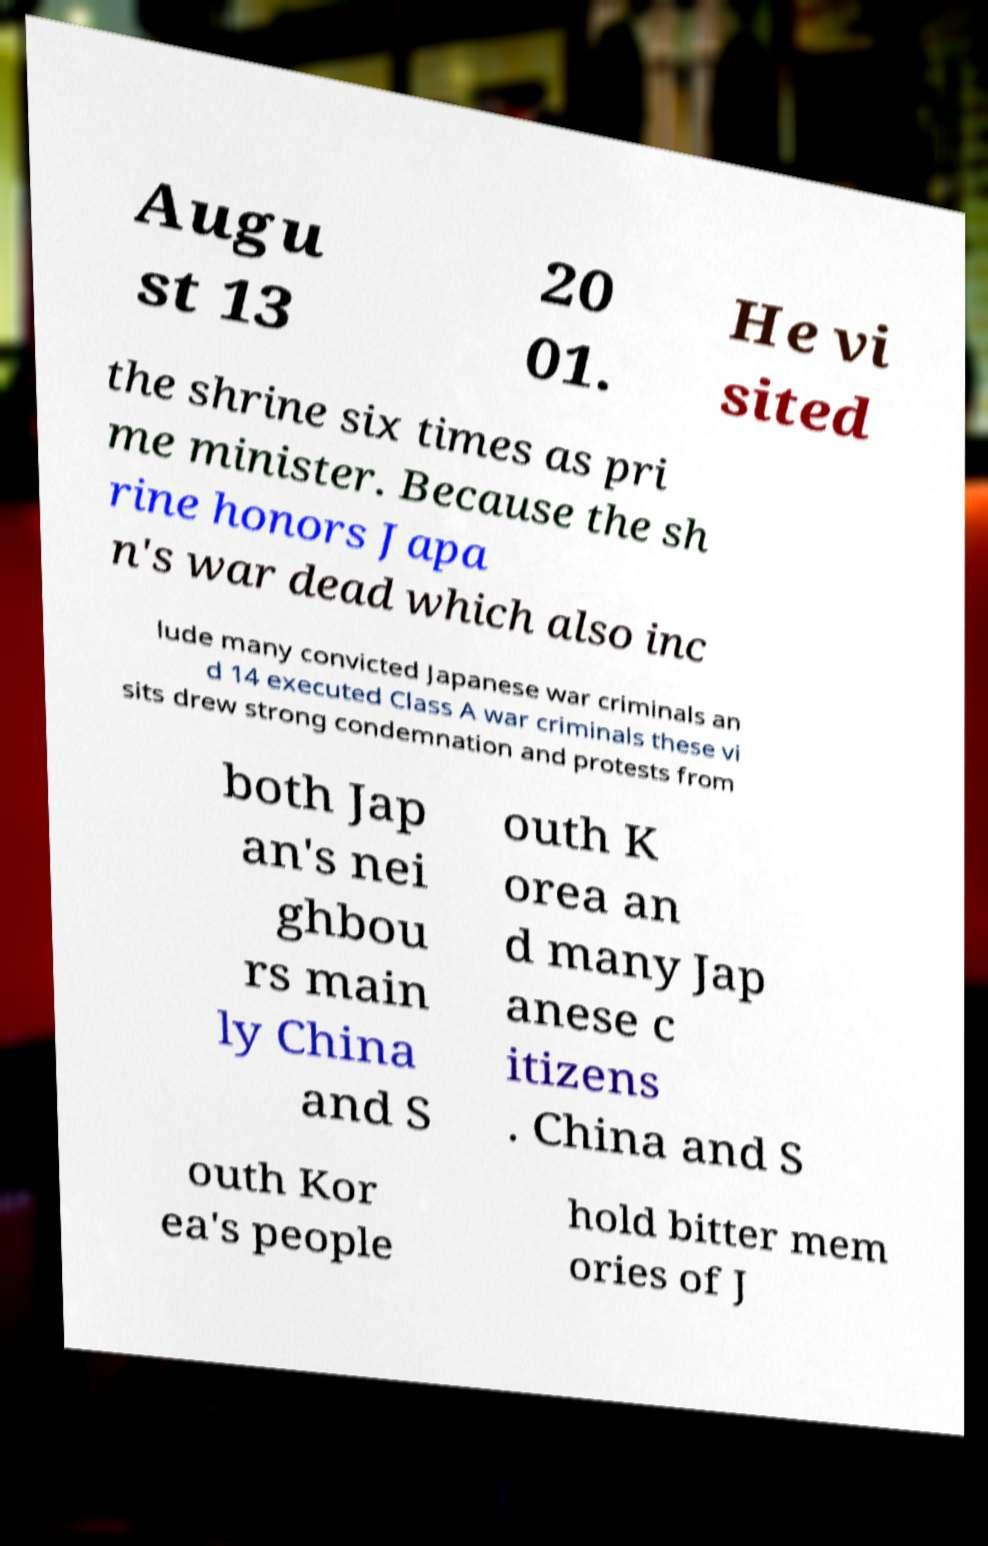Could you extract and type out the text from this image? Augu st 13 20 01. He vi sited the shrine six times as pri me minister. Because the sh rine honors Japa n's war dead which also inc lude many convicted Japanese war criminals an d 14 executed Class A war criminals these vi sits drew strong condemnation and protests from both Jap an's nei ghbou rs main ly China and S outh K orea an d many Jap anese c itizens . China and S outh Kor ea's people hold bitter mem ories of J 